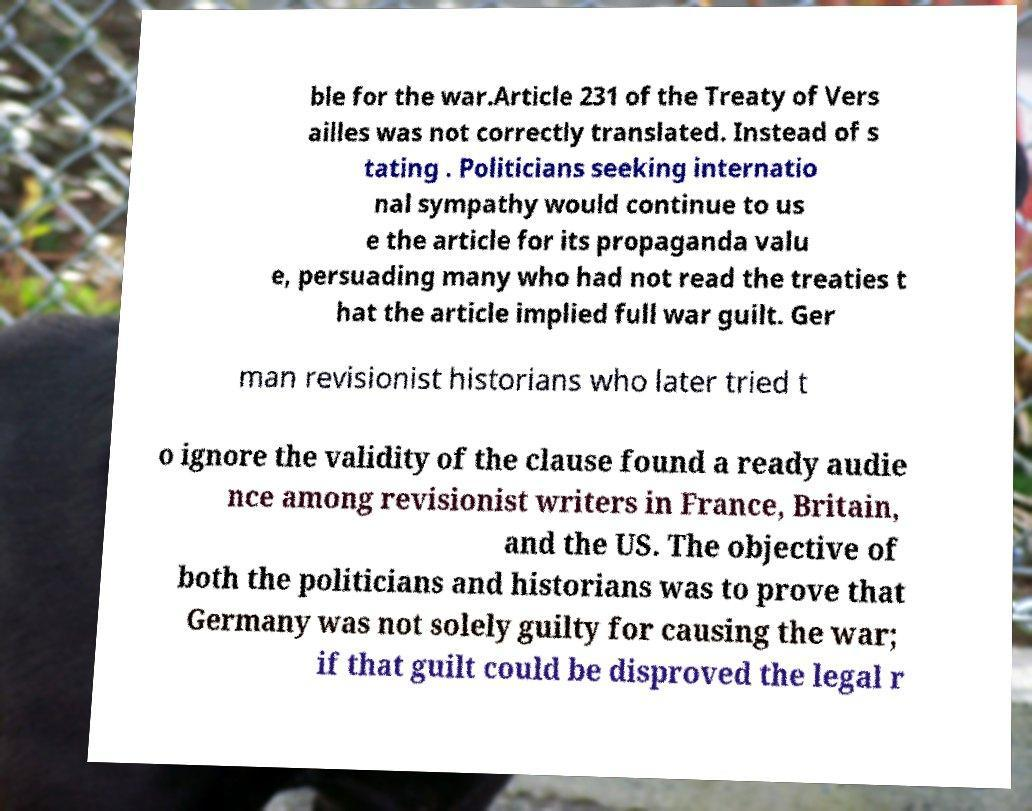Could you assist in decoding the text presented in this image and type it out clearly? ble for the war.Article 231 of the Treaty of Vers ailles was not correctly translated. Instead of s tating . Politicians seeking internatio nal sympathy would continue to us e the article for its propaganda valu e, persuading many who had not read the treaties t hat the article implied full war guilt. Ger man revisionist historians who later tried t o ignore the validity of the clause found a ready audie nce among revisionist writers in France, Britain, and the US. The objective of both the politicians and historians was to prove that Germany was not solely guilty for causing the war; if that guilt could be disproved the legal r 